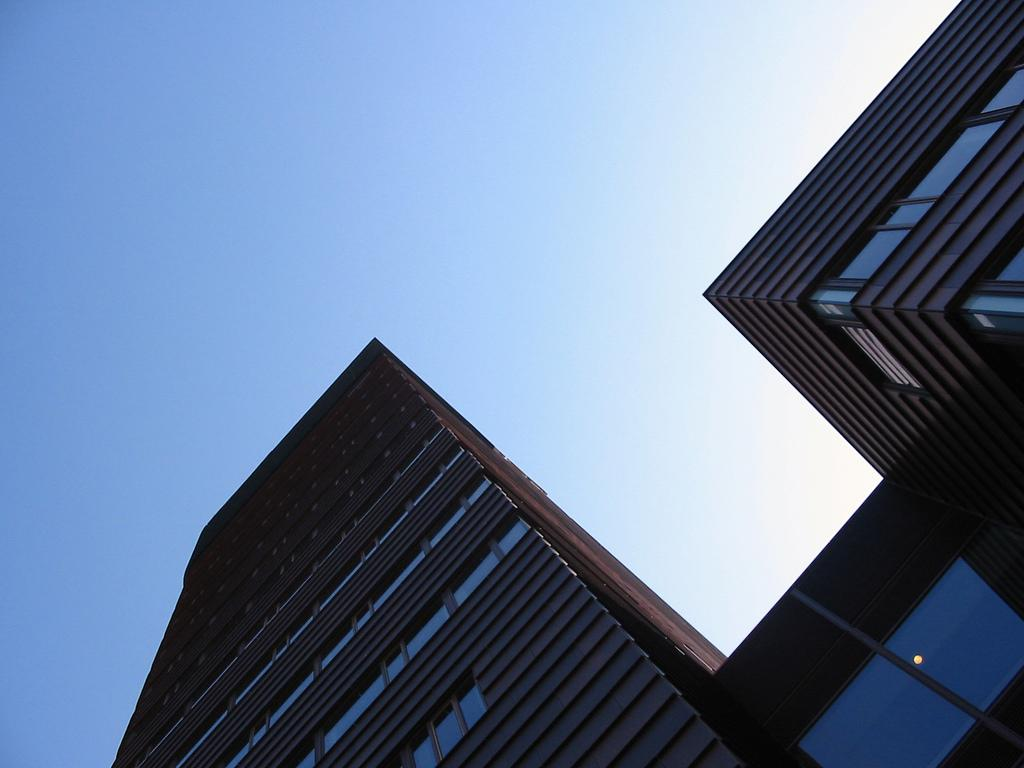What type of structure is visible in the image? There is a building in the image. What color is the sky in the image? The sky is blue in the image. What type of stamp can be seen on the building in the image? There is no stamp visible on the building in the image. What material is the brass sculpture made of in the image? There is no brass sculpture present in the image. 